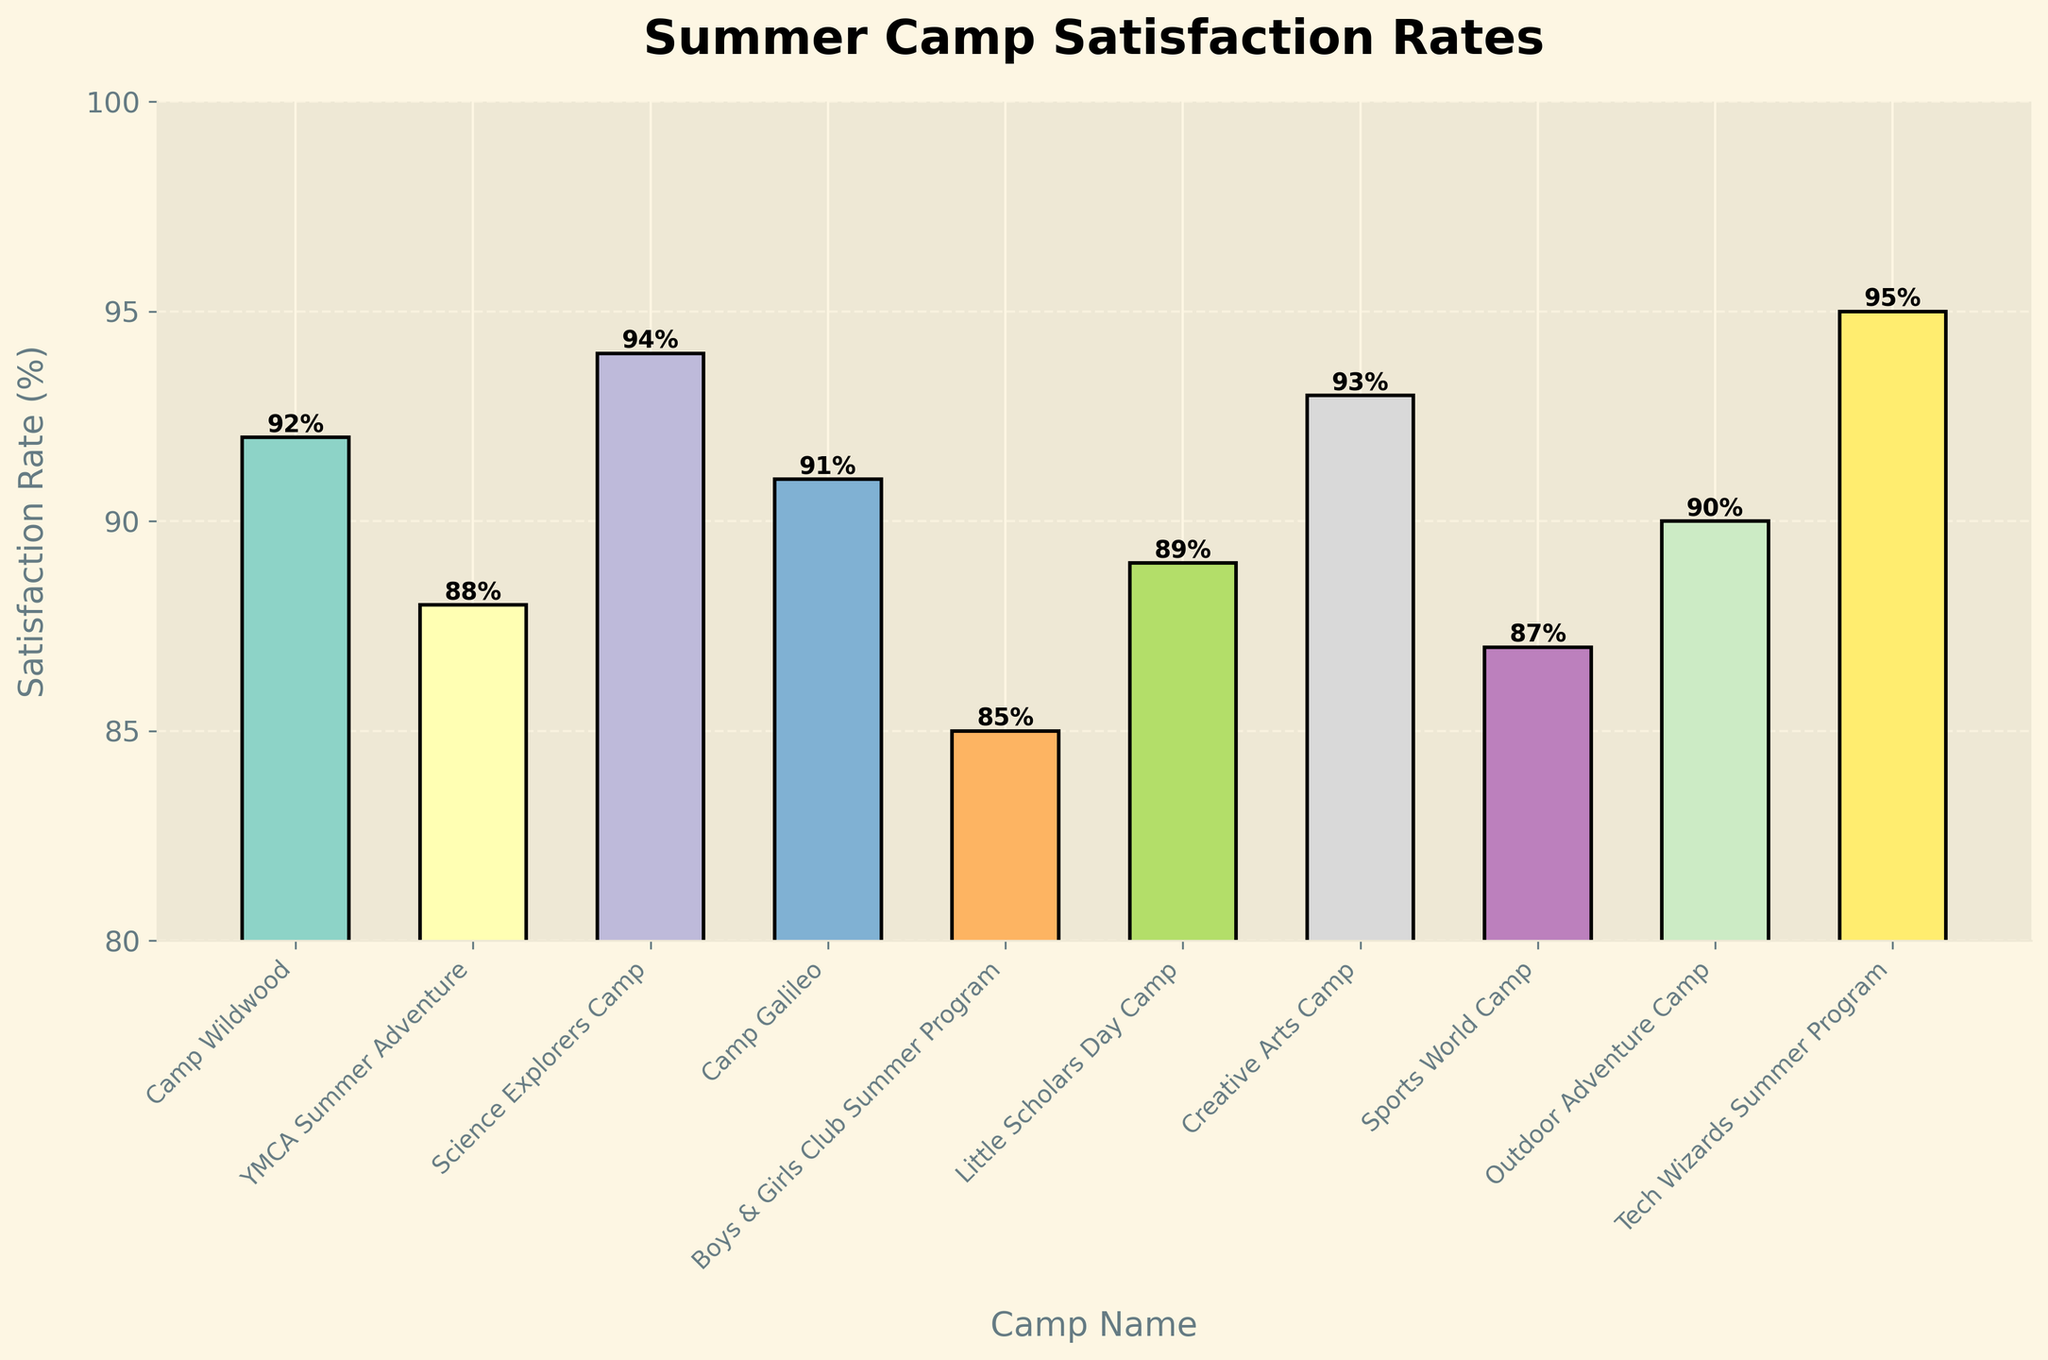Which summer camp has the highest parental satisfaction rate? Look at the bar chart and identify the tallest bar. From the labels on the x-axis, we see that Tech Wizards Summer Program has the highest satisfaction rate of 95%.
Answer: Tech Wizards Summer Program Which camp has the lowest satisfaction rate? Identify the shortest bar on the chart, this is Boys & Girls Club Summer Program with a satisfaction rate of 85%.
Answer: Boys & Girls Club Summer Program What's the difference in satisfaction rates between the highest and lowest-rated camps? Calculate the difference between the highest satisfaction rate (95% for Tech Wizards Summer Program) and the lowest satisfaction rate (85% for Boys & Girls Club Summer Program). 95% - 85% = 10%.
Answer: 10% What is the average satisfaction rate of all the camps? Add all the satisfaction rates and divide by the number of camps. (92 + 88 + 94 + 91 + 85 + 89 + 93 + 87 + 90 + 95) / 10 = 90.4%.
Answer: 90.4% How many camps have a satisfaction rate above 90%? Count the number of bars with heights above 90% on the chart. Those are 92%, 94%, 91%, 93%, and 95%, totaling 5 camps.
Answer: 5 Which two camps have the closest satisfaction rates? Compare the satisfaction rates of all camps and find the smallest difference. Camp Wildwood and Camp Galileo both have rates of 92% and 91%, respectively, with a difference of 1%.
Answer: Camp Wildwood and Camp Galileo What is the combined satisfaction rate of Science Explorers Camp, Creative Arts Camp, and Tech Wizards Summer Program? Add their satisfaction rates together: 94% + 93% + 95% = 282%.
Answer: 282% What is the ratio of the satisfaction rate of Little Scholars Day Camp to YMCA Summer Adventure? Divide the satisfaction rate of Little Scholars Day Camp (89%) by the rate of YMCA Summer Adventure (88%). 89% / 88% ≈ 1.01.
Answer: 1.01 Is the satisfaction rate of Outdoor Adventure Camp greater than that of Sports World Camp? Compare the satisfaction rates of Outdoor Adventure Camp (90%) and Sports World Camp (87%). 90% is greater than 87%.
Answer: Yes What's the total number of camps with satisfaction rates between 85% and 90% inclusive? Count the number of bars within the range of 85% to 90%. These are Boys & Girls Club Summer Program (85%), YMCA Summer Adventure (88%), Little Scholars Day Camp (89%), and Sports World Camp (87%), totaling 4 camps.
Answer: 4 